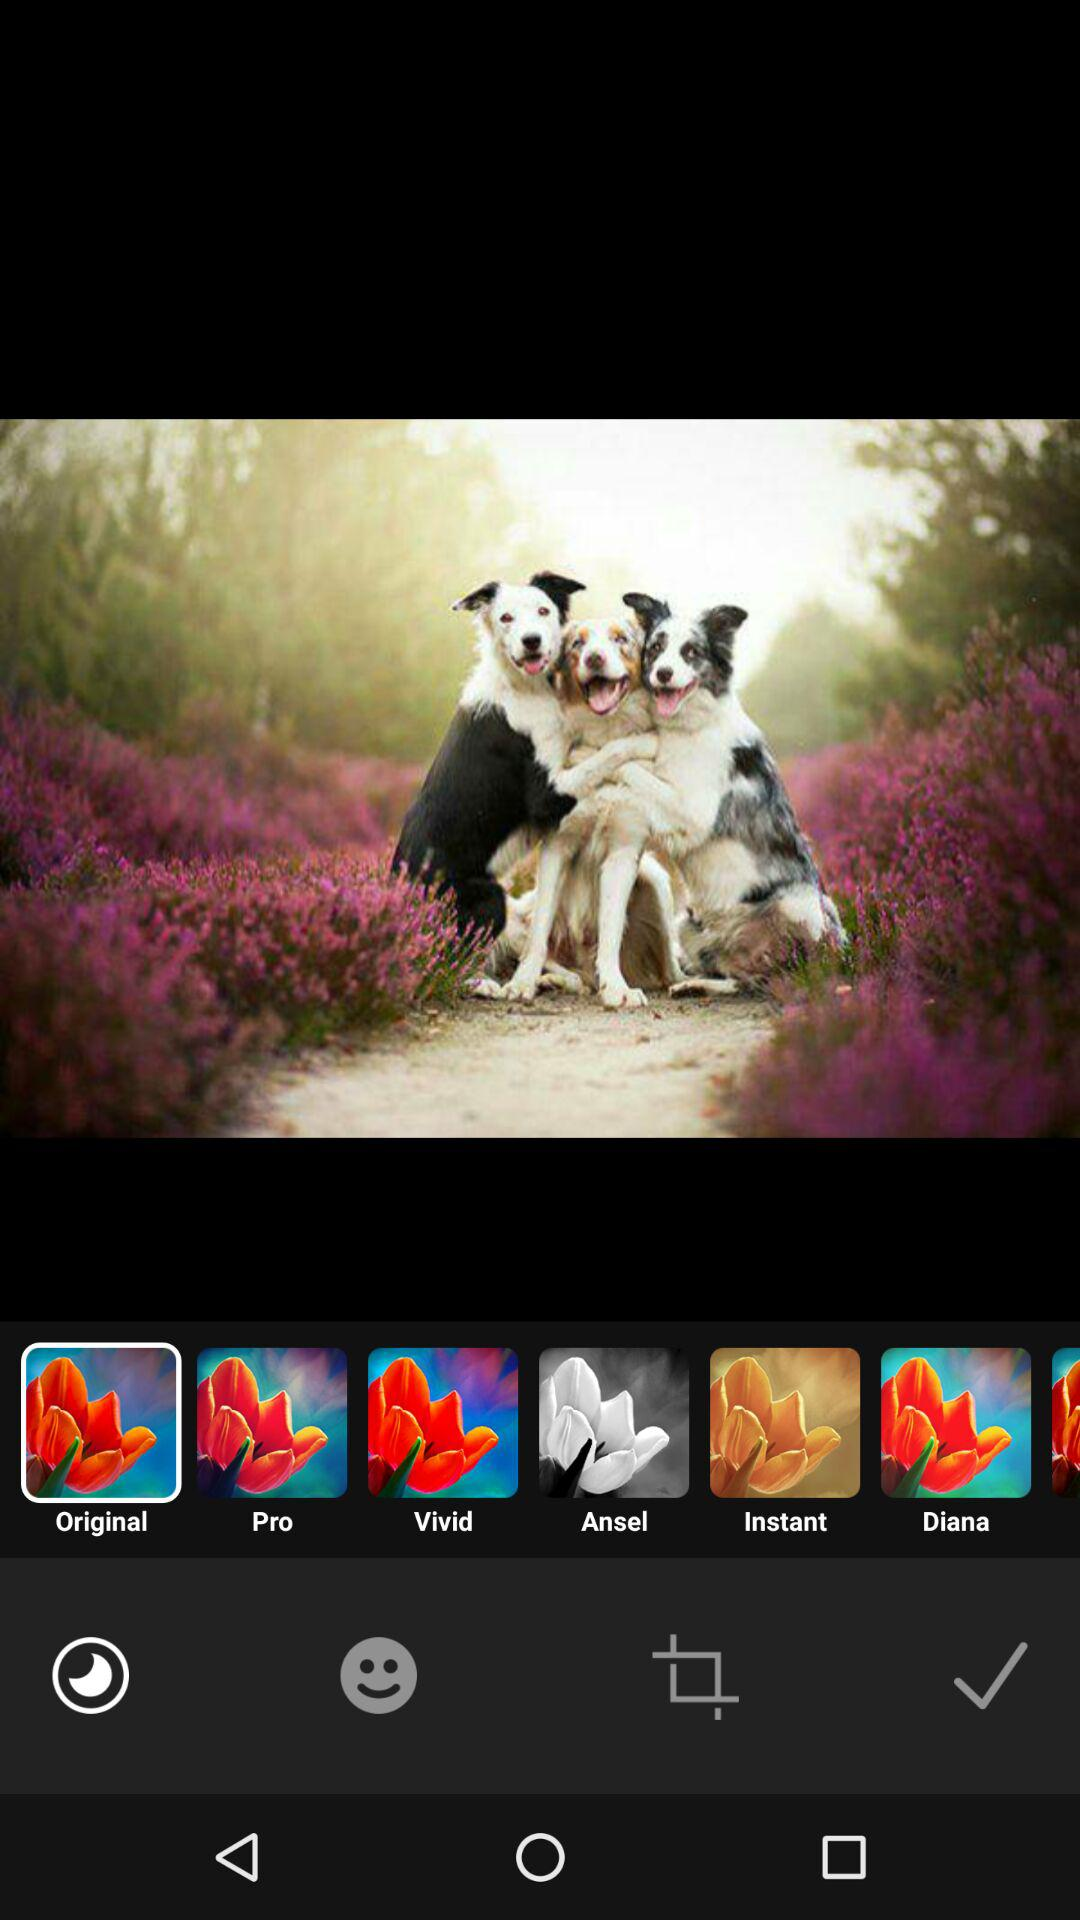How many editing styles are available?
Answer the question using a single word or phrase. 6 